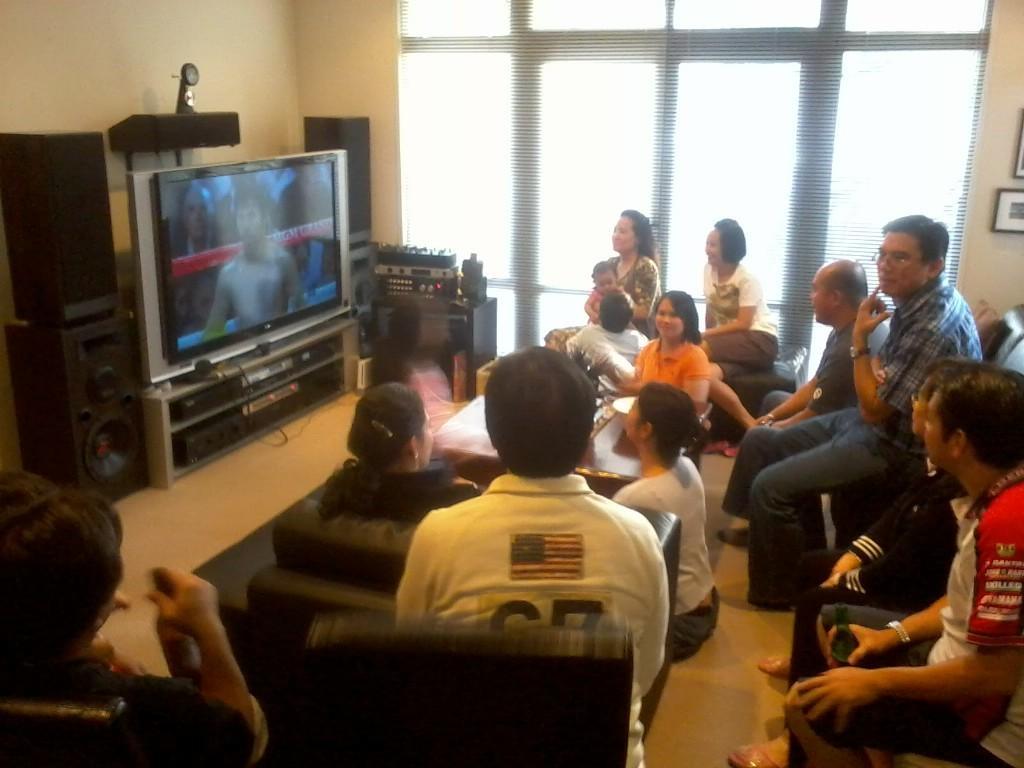Describe this image in one or two sentences. In the picture we can see inside the house with some people sitting on the floor and some are sitting on the chair and watching TV and besides the TV we can see some sound systems and beside it we can see a wall with a part of glass window to it. 